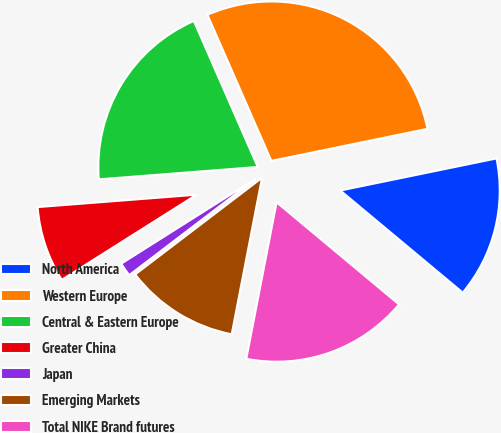Convert chart to OTSL. <chart><loc_0><loc_0><loc_500><loc_500><pie_chart><fcel>North America<fcel>Western Europe<fcel>Central & Eastern Europe<fcel>Greater China<fcel>Japan<fcel>Emerging Markets<fcel>Total NIKE Brand futures<nl><fcel>14.29%<fcel>28.34%<fcel>19.67%<fcel>7.73%<fcel>1.4%<fcel>11.59%<fcel>16.98%<nl></chart> 